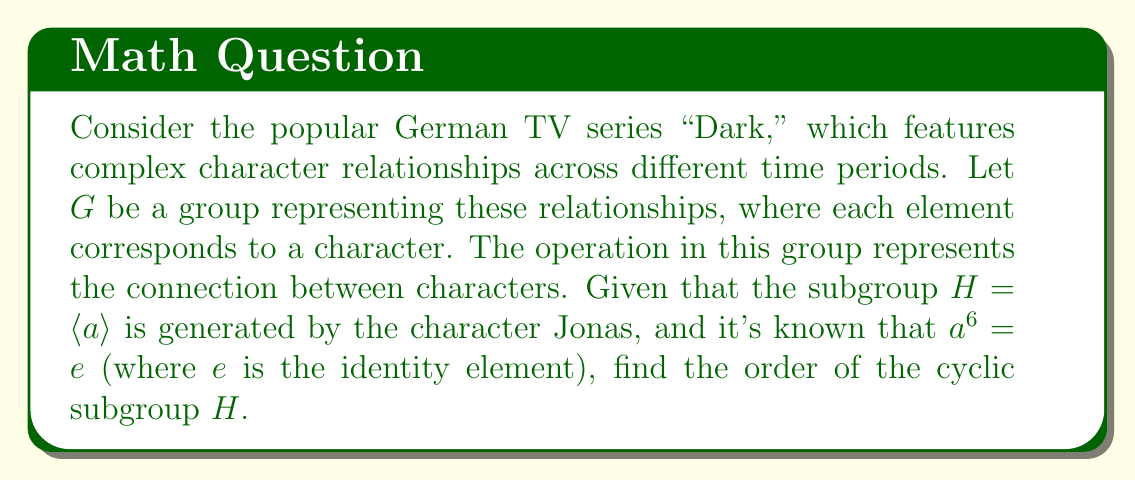Can you answer this question? To find the order of the cyclic subgroup $H = \langle a \rangle$, we need to determine the smallest positive integer $n$ such that $a^n = e$, where $e$ is the identity element of the group.

Given information:
1. $H = \langle a \rangle$ is a cyclic subgroup generated by $a$ (representing Jonas).
2. $a^6 = e$

Steps to determine the order:

1. The fact that $a^6 = e$ tells us that the order of $a$ is a divisor of 6.
2. The possible divisors of 6 are 1, 2, 3, and 6.
3. We need to check which of these is the smallest positive integer $n$ such that $a^n = e$.

4. Let's consider each possibility:
   - If $n = 1$, then $a = e$. This is not the case as $a$ represents Jonas, a non-trivial element.
   - If $n = 2$, then $a^2 = e$. We don't have information to confirm or deny this.
   - If $n = 3$, then $a^3 = e$. We don't have information to confirm or deny this.
   - We know that $n = 6$ satisfies the condition $a^6 = e$.

5. Since we don't have information to confirm $n = 2$ or $n = 3$, and we know $n = 6$ works, we conclude that the order of $a$ is 6.

6. In a cyclic subgroup, the order of the subgroup is equal to the order of its generator.

Therefore, the order of the cyclic subgroup $H = \langle a \rangle$ is 6.
Answer: The order of the cyclic subgroup $H$ is 6. 